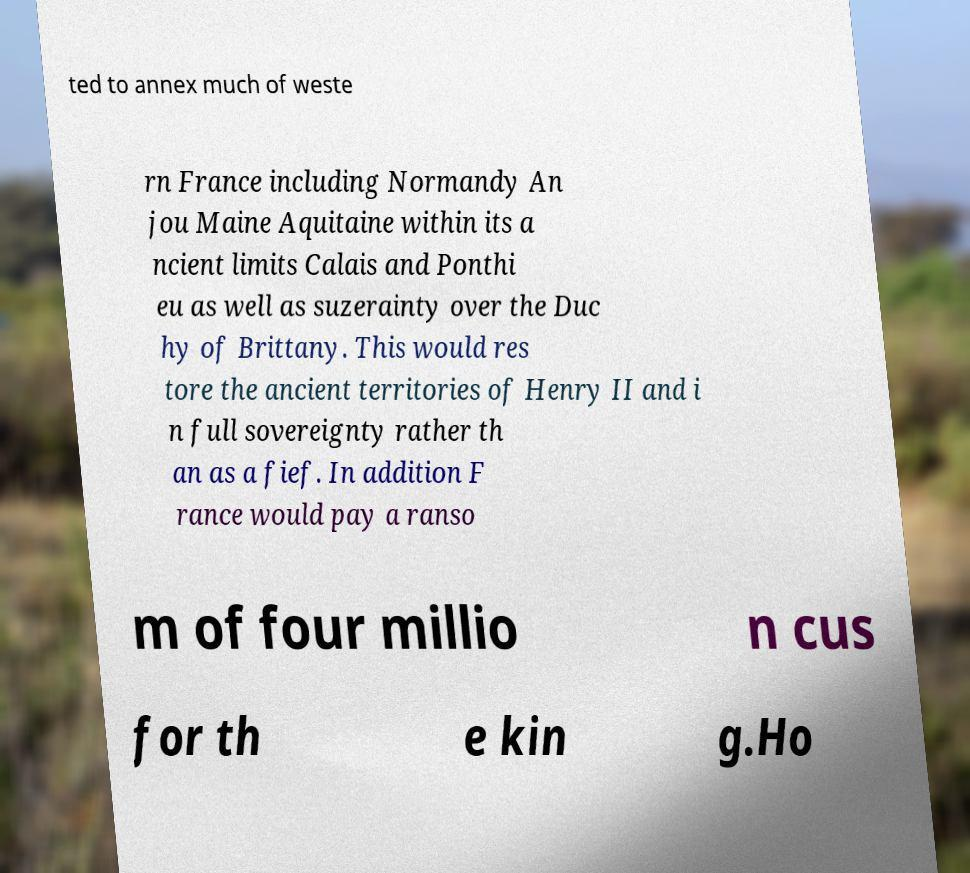Please identify and transcribe the text found in this image. ted to annex much of weste rn France including Normandy An jou Maine Aquitaine within its a ncient limits Calais and Ponthi eu as well as suzerainty over the Duc hy of Brittany. This would res tore the ancient territories of Henry II and i n full sovereignty rather th an as a fief. In addition F rance would pay a ranso m of four millio n cus for th e kin g.Ho 